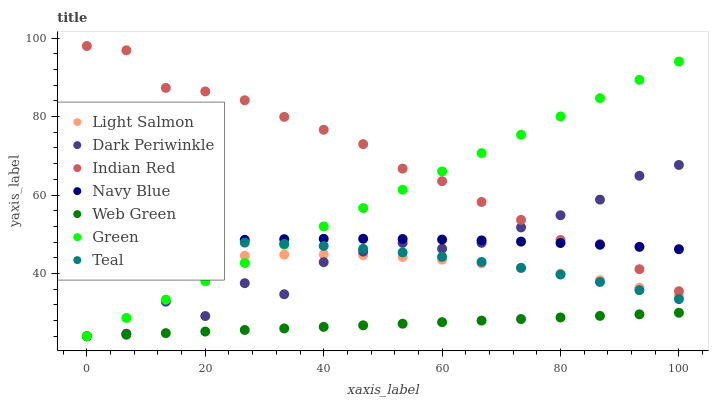Does Web Green have the minimum area under the curve?
Answer yes or no. Yes. Does Indian Red have the maximum area under the curve?
Answer yes or no. Yes. Does Teal have the minimum area under the curve?
Answer yes or no. No. Does Teal have the maximum area under the curve?
Answer yes or no. No. Is Web Green the smoothest?
Answer yes or no. Yes. Is Dark Periwinkle the roughest?
Answer yes or no. Yes. Is Teal the smoothest?
Answer yes or no. No. Is Teal the roughest?
Answer yes or no. No. Does Web Green have the lowest value?
Answer yes or no. Yes. Does Teal have the lowest value?
Answer yes or no. No. Does Indian Red have the highest value?
Answer yes or no. Yes. Does Teal have the highest value?
Answer yes or no. No. Is Light Salmon less than Navy Blue?
Answer yes or no. Yes. Is Indian Red greater than Web Green?
Answer yes or no. Yes. Does Green intersect Teal?
Answer yes or no. Yes. Is Green less than Teal?
Answer yes or no. No. Is Green greater than Teal?
Answer yes or no. No. Does Light Salmon intersect Navy Blue?
Answer yes or no. No. 